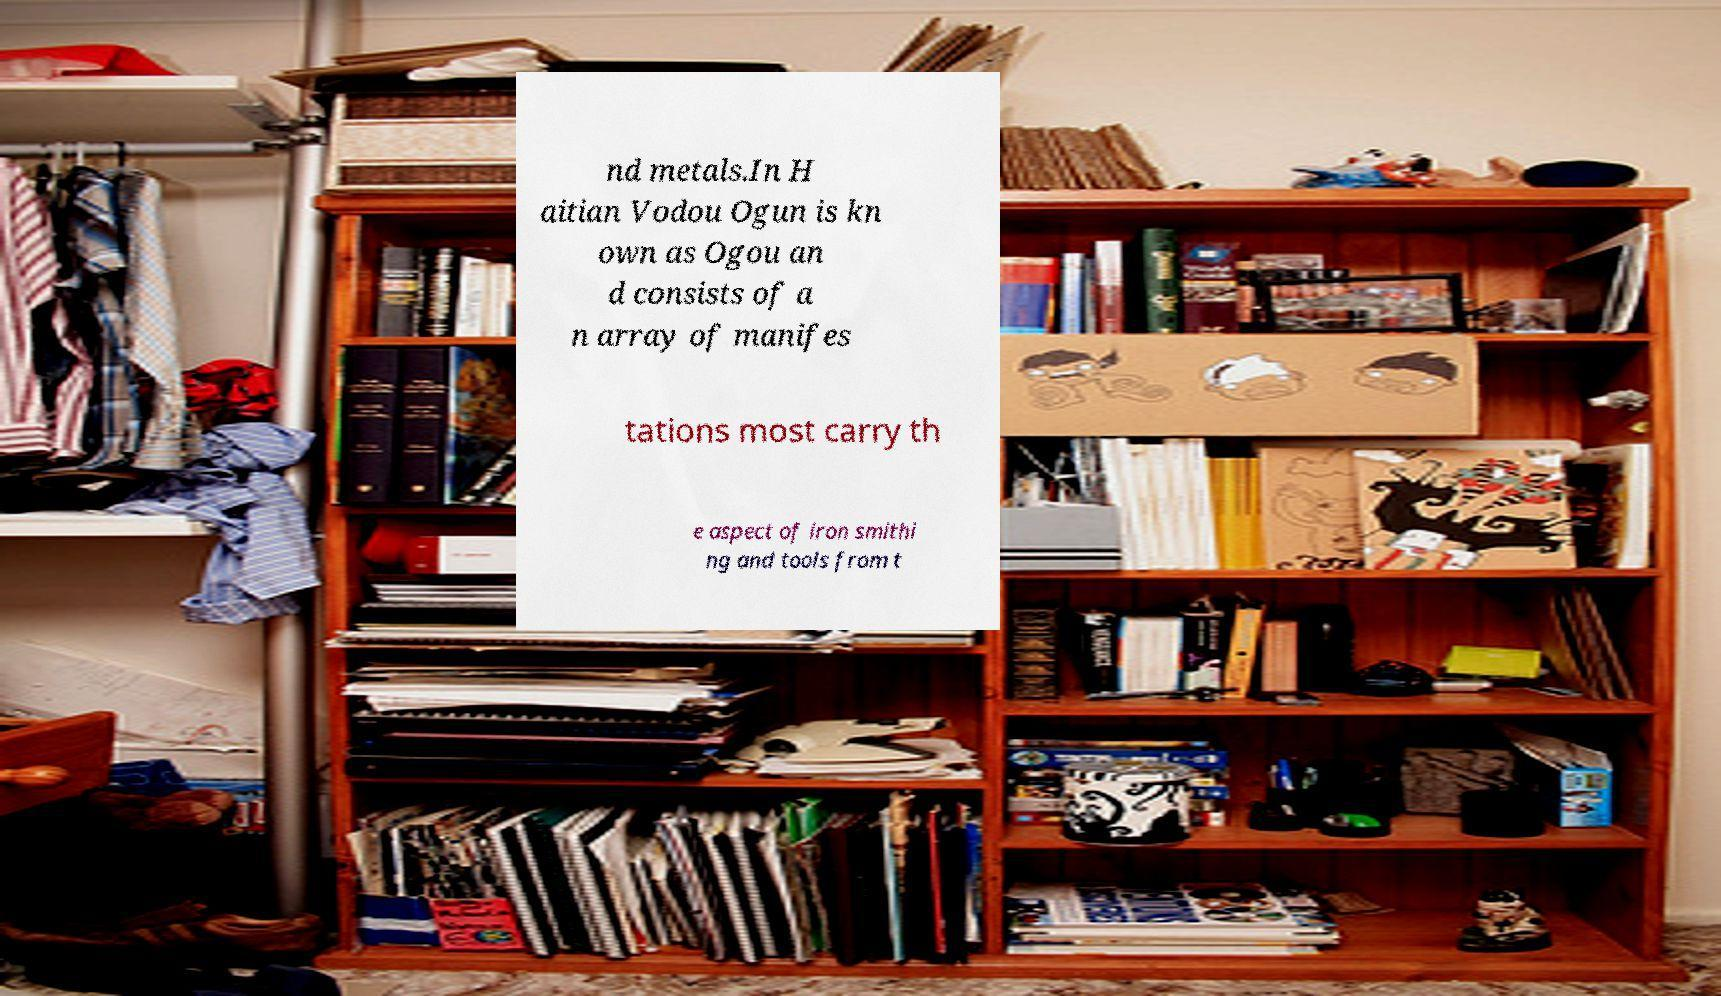Please read and relay the text visible in this image. What does it say? nd metals.In H aitian Vodou Ogun is kn own as Ogou an d consists of a n array of manifes tations most carry th e aspect of iron smithi ng and tools from t 